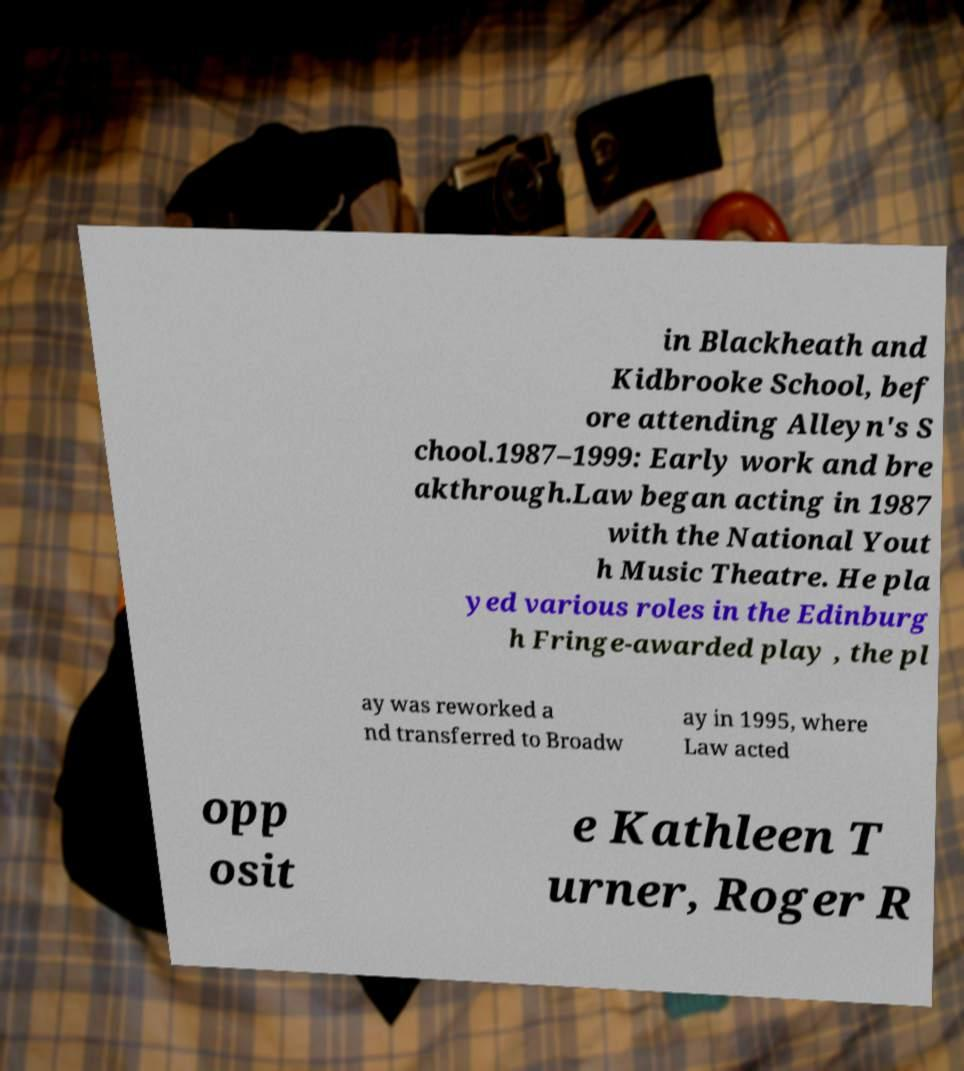Please read and relay the text visible in this image. What does it say? in Blackheath and Kidbrooke School, bef ore attending Alleyn's S chool.1987–1999: Early work and bre akthrough.Law began acting in 1987 with the National Yout h Music Theatre. He pla yed various roles in the Edinburg h Fringe-awarded play , the pl ay was reworked a nd transferred to Broadw ay in 1995, where Law acted opp osit e Kathleen T urner, Roger R 